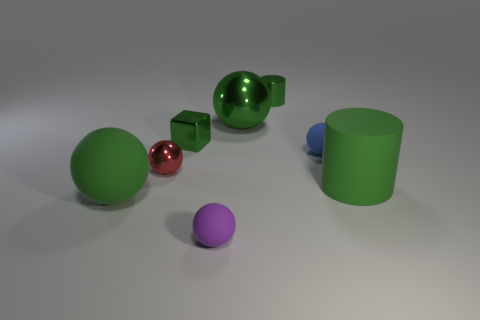What number of green objects are metallic things or tiny matte things?
Make the answer very short. 3. There is a big green thing that is on the right side of the tiny green metallic cylinder; what material is it?
Your answer should be compact. Rubber. There is a big ball that is behind the big green cylinder; what number of green shiny blocks are behind it?
Your response must be concise. 0. What number of other purple rubber objects have the same shape as the tiny purple rubber object?
Make the answer very short. 0. What number of purple metal balls are there?
Ensure brevity in your answer.  0. There is a matte object behind the red object; what color is it?
Offer a terse response. Blue. The tiny matte thing that is left of the green cylinder behind the green matte cylinder is what color?
Make the answer very short. Purple. What is the color of the other matte ball that is the same size as the purple ball?
Provide a succinct answer. Blue. What number of objects are both in front of the green block and to the right of the big matte sphere?
Provide a succinct answer. 4. There is a matte object that is the same color as the large rubber cylinder; what shape is it?
Offer a very short reply. Sphere. 